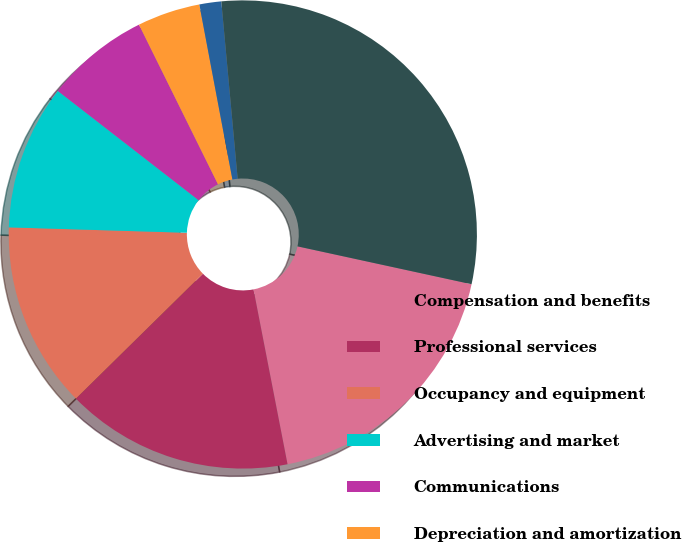<chart> <loc_0><loc_0><loc_500><loc_500><pie_chart><fcel>Compensation and benefits<fcel>Professional services<fcel>Occupancy and equipment<fcel>Advertising and market<fcel>Communications<fcel>Depreciation and amortization<fcel>Other<fcel>Total expenses excluding<nl><fcel>18.53%<fcel>15.69%<fcel>12.85%<fcel>10.02%<fcel>7.18%<fcel>4.34%<fcel>1.51%<fcel>29.87%<nl></chart> 